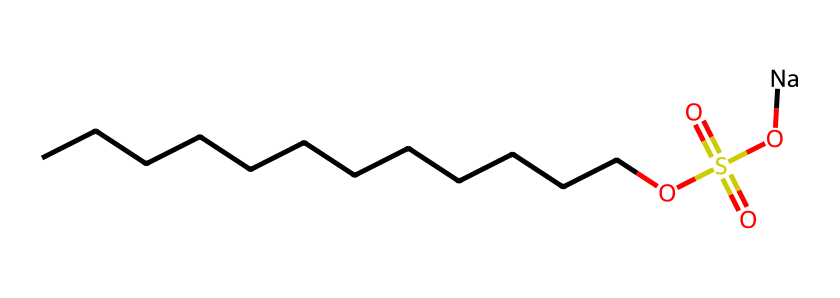How many carbon atoms are in this molecule? By examining the SMILES representation (CCCCCCCCCCCC), we can count the number of "C" characters. In this case, there are 12 carbon atoms linked in a straight chain.
Answer: 12 What type of functional group is present in this chemical? The presence of "OS(=O)(=O)O" indicates the attachment of a sulfate group (-OSO3H) which is a sulfonic acid functional group.
Answer: sulfonic acid Is this chemical a non-electrolyte? Non-electrolytes are substances that do not dissociate into ions in solution. In this molecule, the alkyl chain and the structure suggest it does not dissociate significantly.
Answer: yes What is the overall charge of the molecule? The inclusion of "[Na]" at the end suggests the presence of sodium, which carries a positive charge. The remainder of the molecule is neutral, indicating a net charge of zero.
Answer: zero What does the presence of the long carbon chain imply about its solubility? The long carbon chain generally indicates hydrophobic characteristics, which suggest that the molecule may have low solubility in water but is better in organic solvents.
Answer: low solubility What does the sulfate group contribute to the properties of this detergent? The sulfate group increases the hydrophilicity of the molecule, allowing it to interact better with water, enhancing its ability to clean.
Answer: increases hydrophilicity 